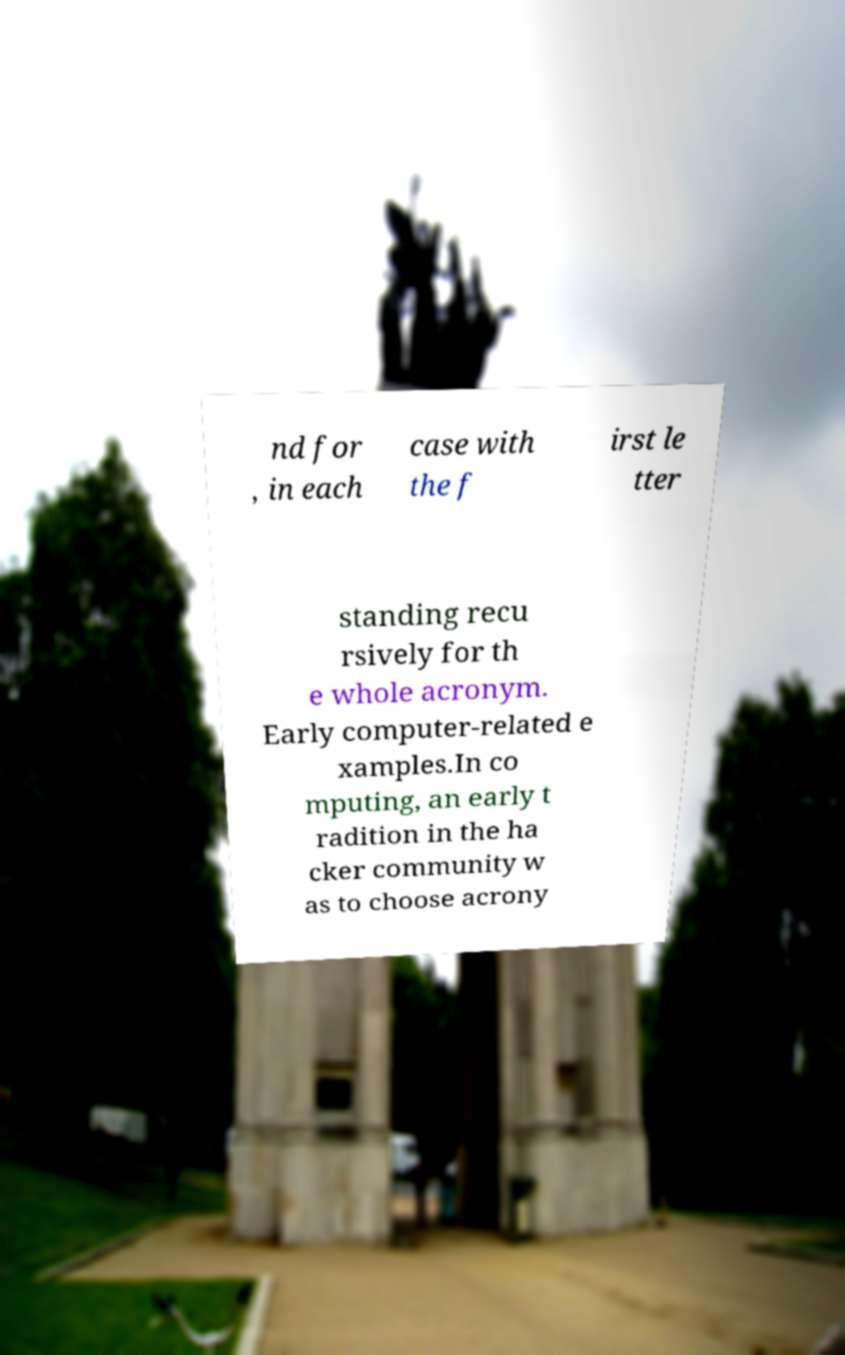I need the written content from this picture converted into text. Can you do that? nd for , in each case with the f irst le tter standing recu rsively for th e whole acronym. Early computer-related e xamples.In co mputing, an early t radition in the ha cker community w as to choose acrony 